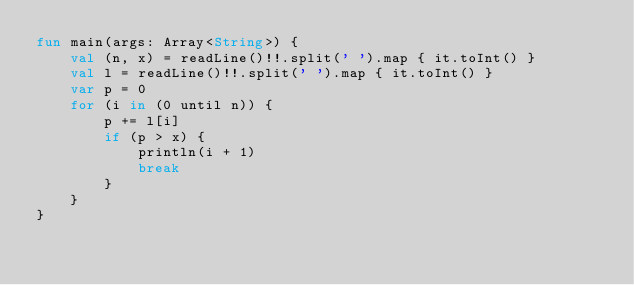<code> <loc_0><loc_0><loc_500><loc_500><_Kotlin_>fun main(args: Array<String>) {
    val (n, x) = readLine()!!.split(' ').map { it.toInt() }
    val l = readLine()!!.split(' ').map { it.toInt() }
    var p = 0
    for (i in (0 until n)) {
        p += l[i]
        if (p > x) {
            println(i + 1)
            break
        }
    }
}</code> 